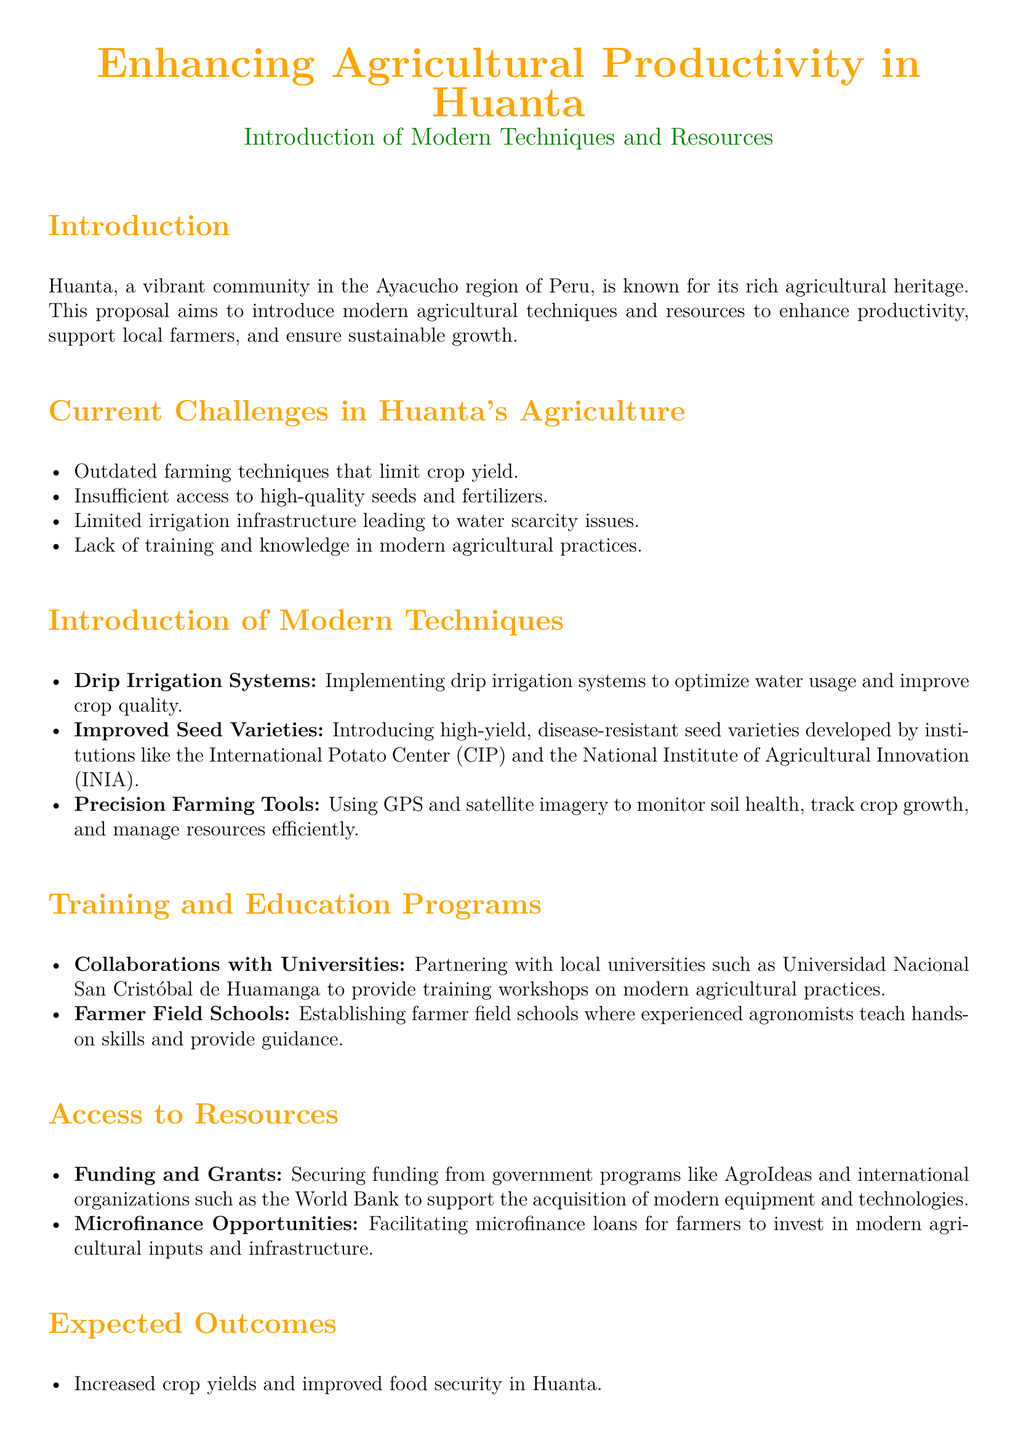What is the main goal of the proposal? The proposal aims to enhance agricultural productivity, support local farmers, and ensure sustainable growth in Huanta.
Answer: enhance agricultural productivity What are the current challenges mentioned in the document? The document lists several challenges, including outdated farming techniques, insufficient access to seeds, limited irrigation infrastructure, and lack of training.
Answer: outdated farming techniques What modern technique is suggested for optimizing water usage? The proposal suggests implementing drip irrigation systems to improve water usage.
Answer: drip irrigation systems Which institution's seed varieties are recommended in the proposal? The proposal recommends improved seed varieties developed by the International Potato Center (CIP) and the National Institute of Agricultural Innovation (INIA).
Answer: International Potato Center (CIP) What type of collaboration is proposed for training programs? The document mentions partnering with local universities for training workshops on modern agricultural practices.
Answer: Collaborations with universities What outcome is expected related to farmer income? The proposal anticipates enhanced farmer income and economic stability as an expected outcome.
Answer: enhanced farmer income What type of funding is mentioned for supporting farmers? The document discusses securing funding from government programs like AgroIdeas and international organizations such as the World Bank.
Answer: AgroIdeas What approach does the proposal outline for Huanta's agricultural sector? The proposal outlines a comprehensive approach to achieving sustainable growth in Huanta's agricultural sector.
Answer: comprehensive approach 